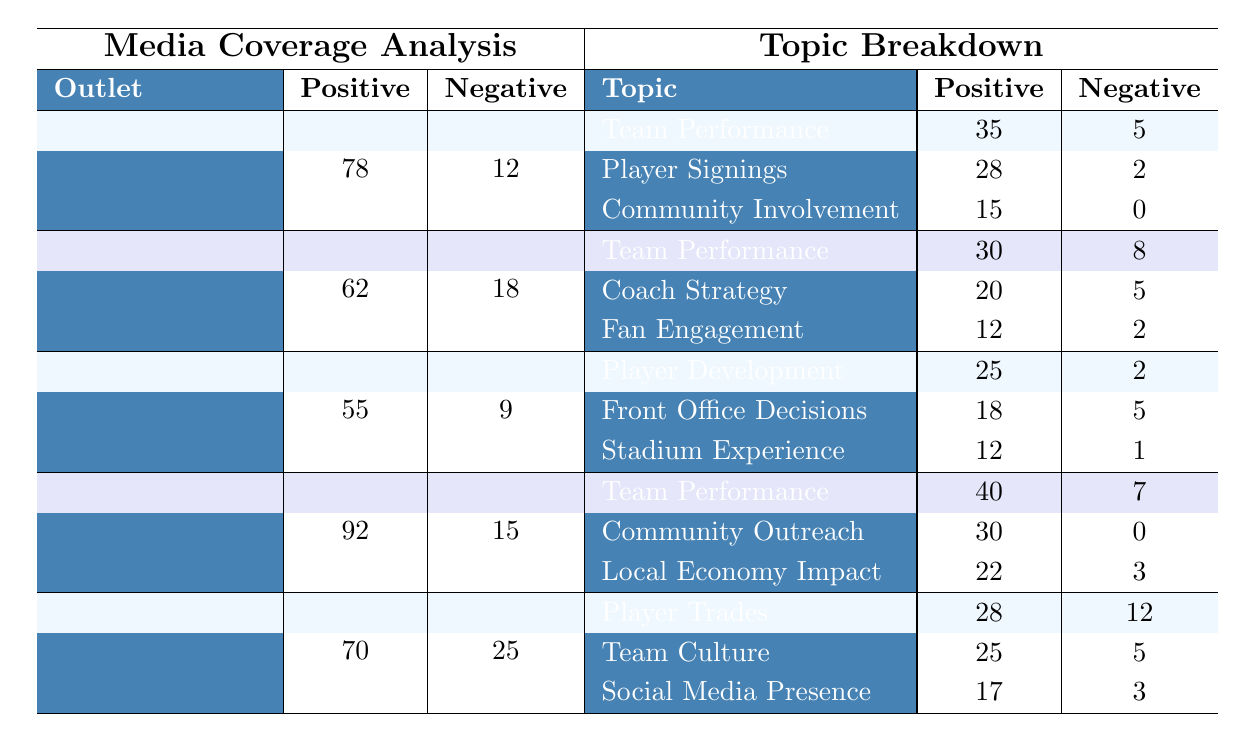What outlet has the highest positive mentions? The outlets are compared based on their positive mentions. Local Newspaper has 92 positive mentions, which is higher than all others listed (ESPN: 78, Sports Illustrated: 62, The Athletic: 55, Bleacher Report: 70).
Answer: Local Newspaper Which topic has the most negative mentions in the ESPN section? From the ESPN section, we examine each topic's negative mentions: Team Performance has 5, Player Signings has 2, and Community Involvement has 0. The topic with the highest negative mentions is Team Performance with 5.
Answer: Team Performance What is the total number of negative mentions from all outlets? The total negative mentions are calculated by adding the negative mentions: 12 (ESPN) + 18 (Sports Illustrated) + 9 (The Athletic) + 15 (Local Newspaper) + 25 (Bleacher Report) = 79.
Answer: 79 Is the number of positive mentions for Player Development more than double the negative mentions in The Athletic? In The Athletic, Player Development has 25 positive mentions and 2 negative mentions. Doubling the negative mentions gives 2 * 2 = 4; since 25 is more than 4, the statement is true.
Answer: Yes How does the total positive mentions of Local Newspaper compare to the total of Bleacher Report? We find the totals: Local Newspaper has 92 positive mentions, and Bleacher Report has 70. Comparing these, we see that 92 is greater than 70.
Answer: Greater What is the average number of positive mentions across all news outlets? The averages are calculated by summing all positive mentions (78 + 62 + 55 + 92 + 70 = 357) and then dividing by the number of outlets (5). This results in 357 / 5 = 71.4.
Answer: 71.4 Which outlet has the highest number of mentions for Community Outreach? From the data provided, Local Newspaper has Community Outreach with 30 positive mentions and 0 negative. Other outlets do not have Community Outreach mentioned, which makes Local Newspaper the only one offering it.
Answer: Local Newspaper What percentage of mentions about Team Performance are positive in Sports Illustrated? In Sports Illustrated, Team Performance has 30 positive mentions and 8 negative mentions. The total mentions for Team Performance are 30 + 8 = 38. The percentage of positive mentions is (30/38) * 100%, which is approximately 78.95%.
Answer: Approximately 78.95% 